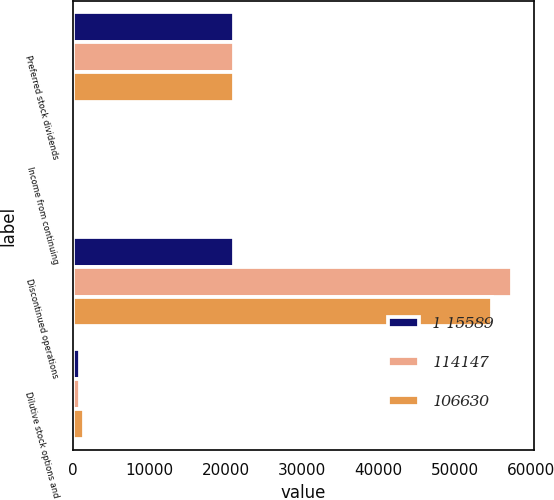Convert chart. <chart><loc_0><loc_0><loc_500><loc_500><stacked_bar_chart><ecel><fcel>Preferred stock dividends<fcel>Income from continuing<fcel>Discontinued operations<fcel>Dilutive stock options and<nl><fcel>1 15589<fcel>21130<fcel>0.58<fcel>21130<fcel>990<nl><fcel>114147<fcel>21130<fcel>0.7<fcel>57468<fcel>887<nl><fcel>106630<fcel>21130<fcel>0.71<fcel>54893<fcel>1508<nl></chart> 